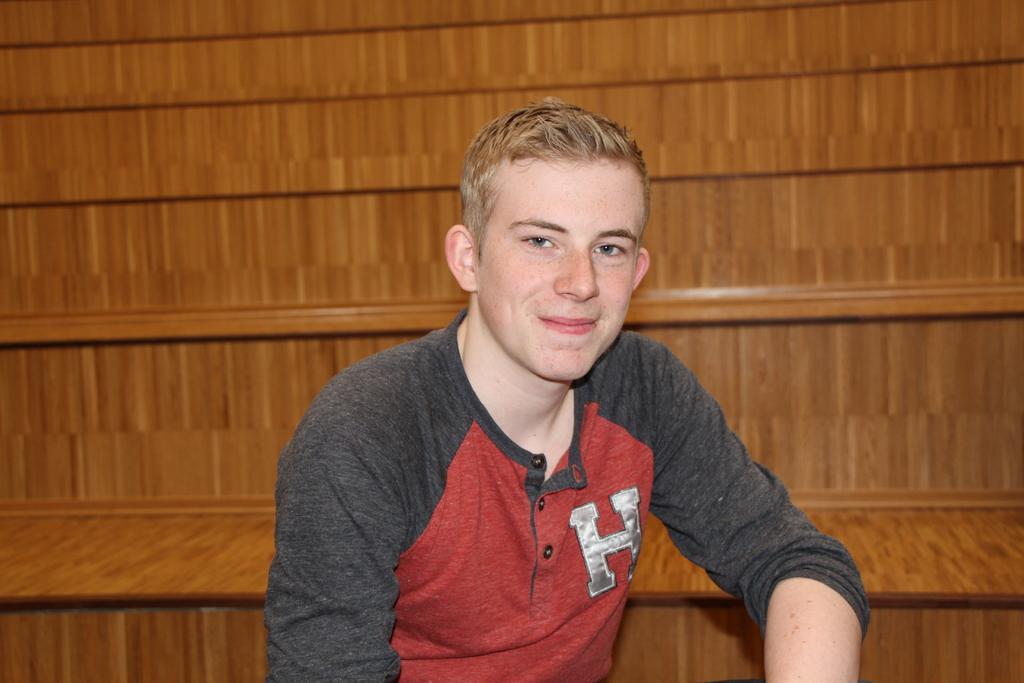Can you describe this image briefly? In this image we can see a person smiling and posing for a photo and in the background, we can see the wooden structure which looks like the stairs. 